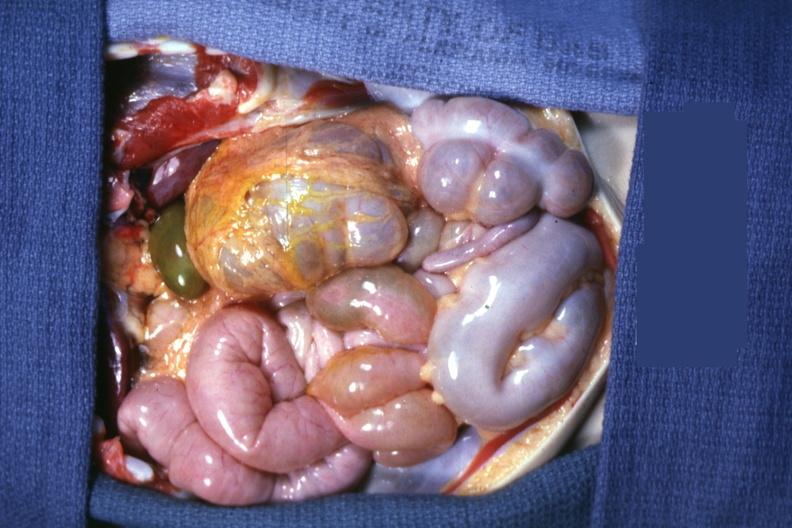s abdomen present?
Answer the question using a single word or phrase. Yes 